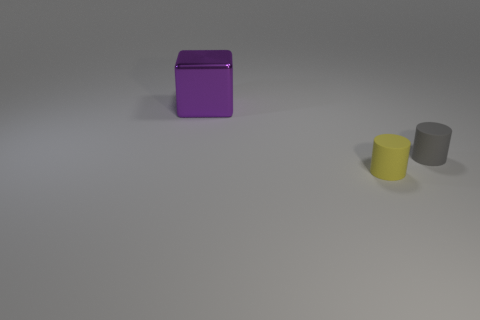Is there any other thing that is the same material as the large cube?
Offer a terse response. No. Is there a tiny yellow object made of the same material as the gray cylinder?
Give a very brief answer. Yes. What size is the purple thing?
Provide a short and direct response. Large. What number of yellow things are small metal blocks or tiny objects?
Provide a succinct answer. 1. How many small yellow things have the same shape as the small gray matte object?
Keep it short and to the point. 1. What number of yellow rubber cylinders have the same size as the gray rubber cylinder?
Provide a short and direct response. 1. There is a tiny yellow thing that is the same shape as the small gray rubber object; what is it made of?
Offer a terse response. Rubber. There is a tiny matte object on the left side of the gray matte thing; what color is it?
Provide a succinct answer. Yellow. Is the number of gray rubber cylinders that are left of the purple metal object greater than the number of tiny gray cylinders?
Your answer should be compact. No. What is the color of the large shiny object?
Keep it short and to the point. Purple. 